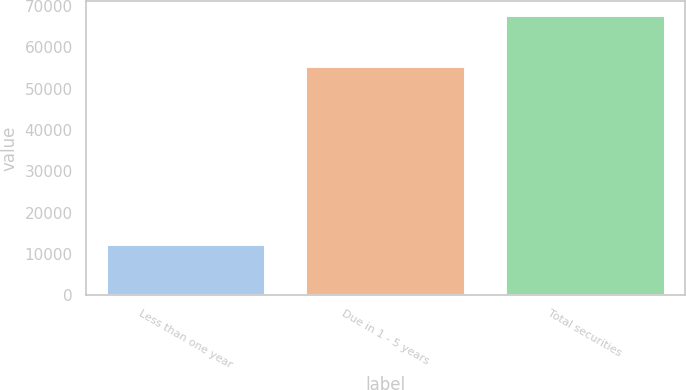<chart> <loc_0><loc_0><loc_500><loc_500><bar_chart><fcel>Less than one year<fcel>Due in 1 - 5 years<fcel>Total securities<nl><fcel>12332<fcel>55410<fcel>67742<nl></chart> 